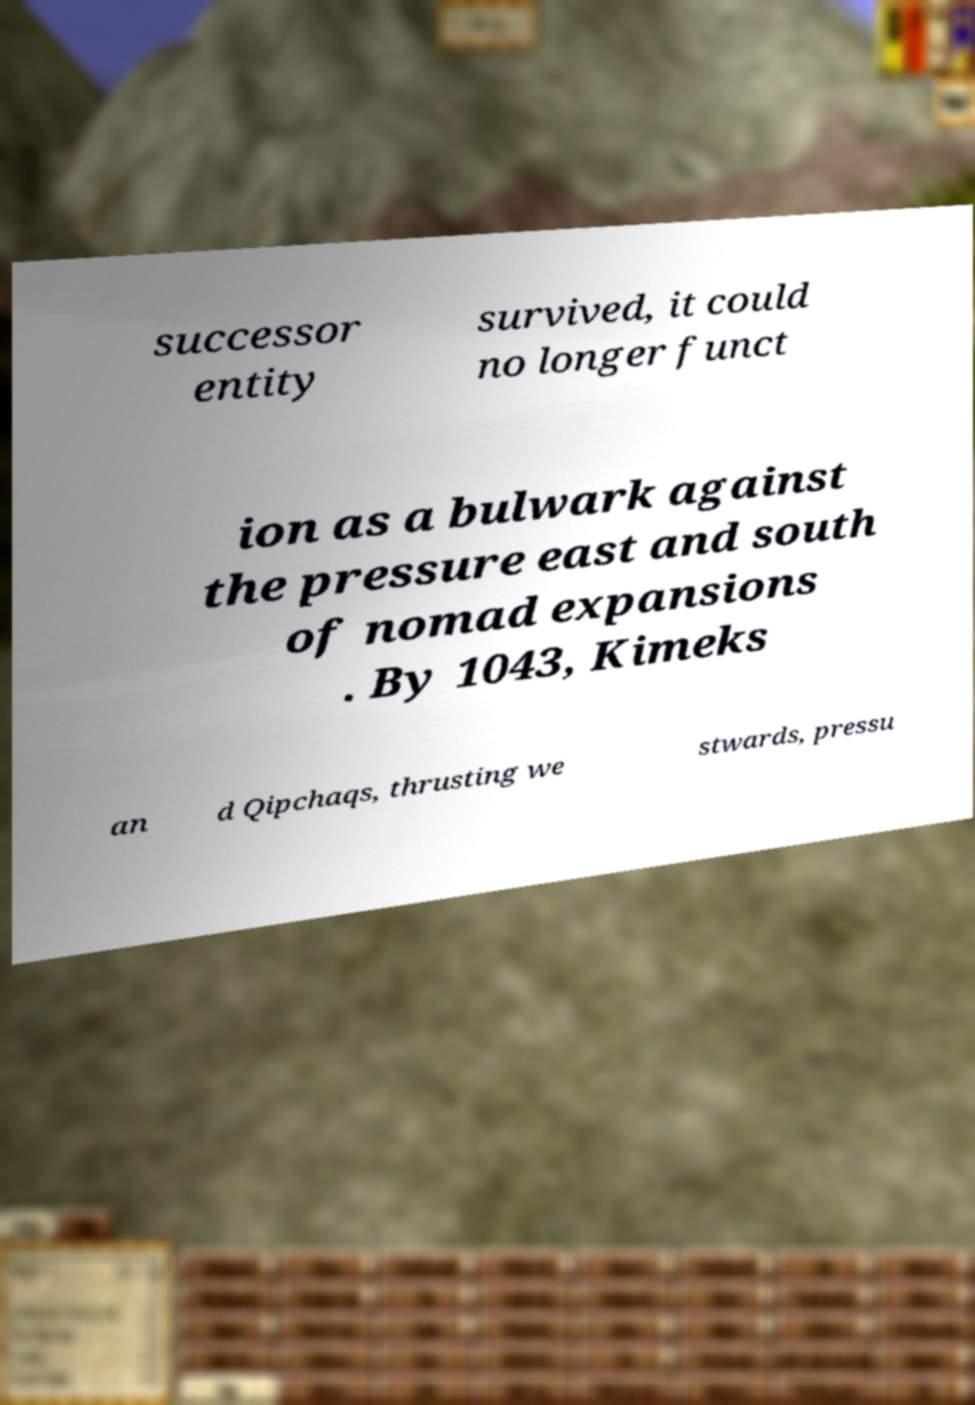Can you accurately transcribe the text from the provided image for me? successor entity survived, it could no longer funct ion as a bulwark against the pressure east and south of nomad expansions . By 1043, Kimeks an d Qipchaqs, thrusting we stwards, pressu 